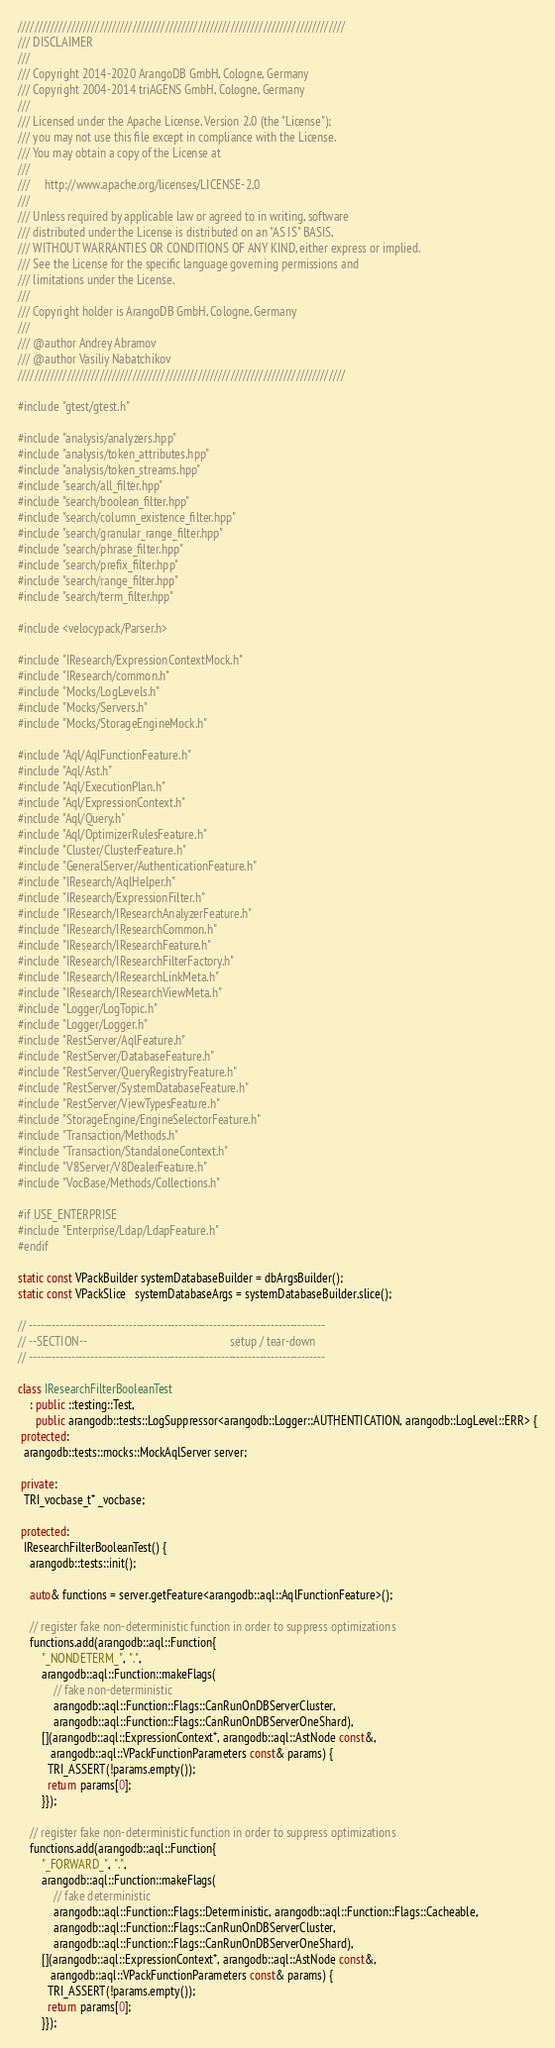<code> <loc_0><loc_0><loc_500><loc_500><_C++_>////////////////////////////////////////////////////////////////////////////////
/// DISCLAIMER
///
/// Copyright 2014-2020 ArangoDB GmbH, Cologne, Germany
/// Copyright 2004-2014 triAGENS GmbH, Cologne, Germany
///
/// Licensed under the Apache License, Version 2.0 (the "License");
/// you may not use this file except in compliance with the License.
/// You may obtain a copy of the License at
///
///     http://www.apache.org/licenses/LICENSE-2.0
///
/// Unless required by applicable law or agreed to in writing, software
/// distributed under the License is distributed on an "AS IS" BASIS,
/// WITHOUT WARRANTIES OR CONDITIONS OF ANY KIND, either express or implied.
/// See the License for the specific language governing permissions and
/// limitations under the License.
///
/// Copyright holder is ArangoDB GmbH, Cologne, Germany
///
/// @author Andrey Abramov
/// @author Vasiliy Nabatchikov
////////////////////////////////////////////////////////////////////////////////

#include "gtest/gtest.h"

#include "analysis/analyzers.hpp"
#include "analysis/token_attributes.hpp"
#include "analysis/token_streams.hpp"
#include "search/all_filter.hpp"
#include "search/boolean_filter.hpp"
#include "search/column_existence_filter.hpp"
#include "search/granular_range_filter.hpp"
#include "search/phrase_filter.hpp"
#include "search/prefix_filter.hpp"
#include "search/range_filter.hpp"
#include "search/term_filter.hpp"

#include <velocypack/Parser.h>

#include "IResearch/ExpressionContextMock.h"
#include "IResearch/common.h"
#include "Mocks/LogLevels.h"
#include "Mocks/Servers.h"
#include "Mocks/StorageEngineMock.h"

#include "Aql/AqlFunctionFeature.h"
#include "Aql/Ast.h"
#include "Aql/ExecutionPlan.h"
#include "Aql/ExpressionContext.h"
#include "Aql/Query.h"
#include "Aql/OptimizerRulesFeature.h"
#include "Cluster/ClusterFeature.h"
#include "GeneralServer/AuthenticationFeature.h"
#include "IResearch/AqlHelper.h"
#include "IResearch/ExpressionFilter.h"
#include "IResearch/IResearchAnalyzerFeature.h"
#include "IResearch/IResearchCommon.h"
#include "IResearch/IResearchFeature.h"
#include "IResearch/IResearchFilterFactory.h"
#include "IResearch/IResearchLinkMeta.h"
#include "IResearch/IResearchViewMeta.h"
#include "Logger/LogTopic.h"
#include "Logger/Logger.h"
#include "RestServer/AqlFeature.h"
#include "RestServer/DatabaseFeature.h"
#include "RestServer/QueryRegistryFeature.h"
#include "RestServer/SystemDatabaseFeature.h"
#include "RestServer/ViewTypesFeature.h"
#include "StorageEngine/EngineSelectorFeature.h"
#include "Transaction/Methods.h"
#include "Transaction/StandaloneContext.h"
#include "V8Server/V8DealerFeature.h"
#include "VocBase/Methods/Collections.h"

#if USE_ENTERPRISE
#include "Enterprise/Ldap/LdapFeature.h"
#endif

static const VPackBuilder systemDatabaseBuilder = dbArgsBuilder();
static const VPackSlice   systemDatabaseArgs = systemDatabaseBuilder.slice();

// -----------------------------------------------------------------------------
// --SECTION--                                                 setup / tear-down
// -----------------------------------------------------------------------------

class IResearchFilterBooleanTest
    : public ::testing::Test,
      public arangodb::tests::LogSuppressor<arangodb::Logger::AUTHENTICATION, arangodb::LogLevel::ERR> {
 protected:
  arangodb::tests::mocks::MockAqlServer server;

 private:
  TRI_vocbase_t* _vocbase;

 protected:
  IResearchFilterBooleanTest() {
    arangodb::tests::init();

    auto& functions = server.getFeature<arangodb::aql::AqlFunctionFeature>();

    // register fake non-deterministic function in order to suppress optimizations
    functions.add(arangodb::aql::Function{
        "_NONDETERM_", ".",
        arangodb::aql::Function::makeFlags(
            // fake non-deterministic
            arangodb::aql::Function::Flags::CanRunOnDBServerCluster,
            arangodb::aql::Function::Flags::CanRunOnDBServerOneShard),
        [](arangodb::aql::ExpressionContext*, arangodb::aql::AstNode const&,
           arangodb::aql::VPackFunctionParameters const& params) {
          TRI_ASSERT(!params.empty());
          return params[0];
        }});

    // register fake non-deterministic function in order to suppress optimizations
    functions.add(arangodb::aql::Function{
        "_FORWARD_", ".",
        arangodb::aql::Function::makeFlags(
            // fake deterministic
            arangodb::aql::Function::Flags::Deterministic, arangodb::aql::Function::Flags::Cacheable,
            arangodb::aql::Function::Flags::CanRunOnDBServerCluster,
            arangodb::aql::Function::Flags::CanRunOnDBServerOneShard),
        [](arangodb::aql::ExpressionContext*, arangodb::aql::AstNode const&,
           arangodb::aql::VPackFunctionParameters const& params) {
          TRI_ASSERT(!params.empty());
          return params[0];
        }});
</code> 